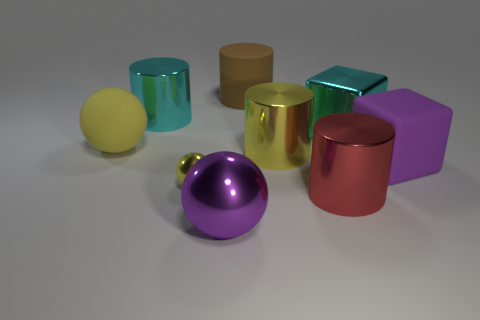There is a big purple thing that is made of the same material as the big yellow ball; what shape is it?
Your response must be concise. Cube. What number of other things are there of the same shape as the tiny yellow metallic object?
Provide a succinct answer. 2. What number of red objects are matte things or small metal objects?
Your answer should be compact. 0. Do the red metal object and the large brown rubber thing have the same shape?
Keep it short and to the point. Yes. Is there a large cylinder in front of the large cyan thing on the left side of the big metallic sphere?
Provide a succinct answer. Yes. Are there the same number of yellow shiny cylinders that are right of the big red metal object and big red cubes?
Keep it short and to the point. Yes. How many other objects are the same size as the yellow rubber sphere?
Provide a succinct answer. 7. Is the material of the large yellow thing that is in front of the large rubber sphere the same as the purple object left of the red metallic cylinder?
Make the answer very short. Yes. There is a yellow shiny thing that is in front of the yellow shiny thing that is on the right side of the big brown thing; what size is it?
Ensure brevity in your answer.  Small. Are there any big cylinders of the same color as the tiny object?
Make the answer very short. Yes. 